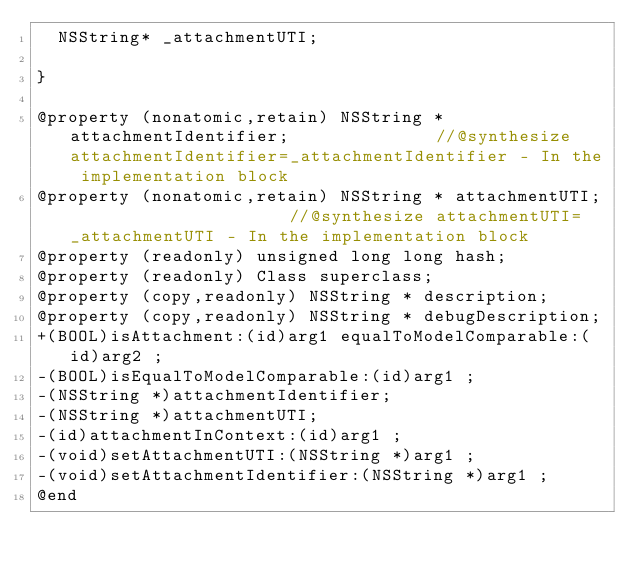Convert code to text. <code><loc_0><loc_0><loc_500><loc_500><_C_>	NSString* _attachmentUTI;

}

@property (nonatomic,retain) NSString * attachmentIdentifier;              //@synthesize attachmentIdentifier=_attachmentIdentifier - In the implementation block
@property (nonatomic,retain) NSString * attachmentUTI;                     //@synthesize attachmentUTI=_attachmentUTI - In the implementation block
@property (readonly) unsigned long long hash; 
@property (readonly) Class superclass; 
@property (copy,readonly) NSString * description; 
@property (copy,readonly) NSString * debugDescription; 
+(BOOL)isAttachment:(id)arg1 equalToModelComparable:(id)arg2 ;
-(BOOL)isEqualToModelComparable:(id)arg1 ;
-(NSString *)attachmentIdentifier;
-(NSString *)attachmentUTI;
-(id)attachmentInContext:(id)arg1 ;
-(void)setAttachmentUTI:(NSString *)arg1 ;
-(void)setAttachmentIdentifier:(NSString *)arg1 ;
@end

</code> 